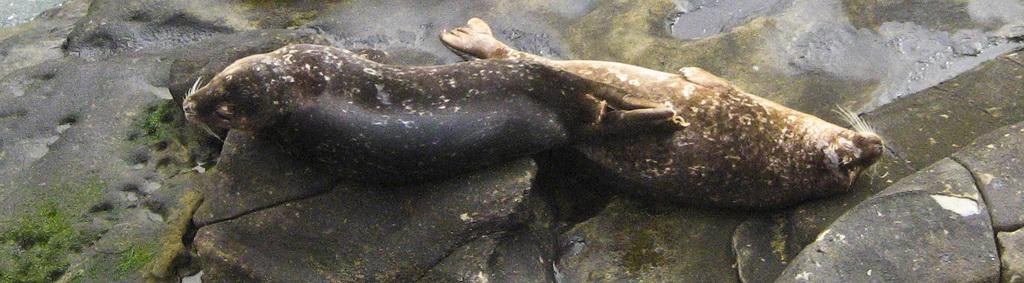How many seals are in the image? There are two seals in the image. What are the colors of the seals? One seal is black in color, and the other seal is brown and cream in color. What are the seals resting on in the image? The seals are on stones. What type of appliance can be seen in the image? There is no appliance present in the image; it features two seals on stones. How many family members are visible in the image? There are no family members present in the image; it features two seals on stones. 